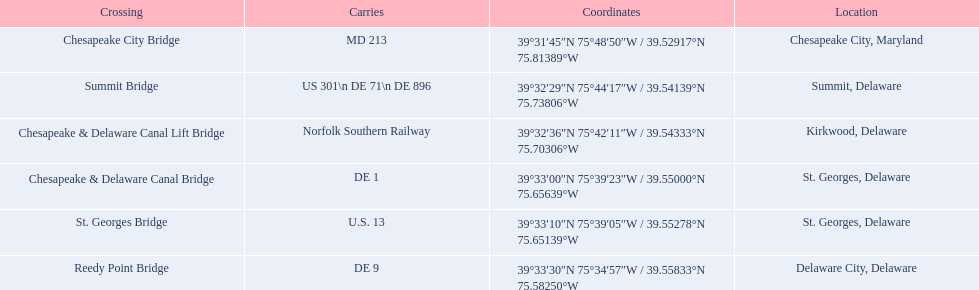Parse the full table in json format. {'header': ['Crossing', 'Carries', 'Coordinates', 'Location'], 'rows': [['Chesapeake City Bridge', 'MD 213', '39°31′45″N 75°48′50″W\ufeff / \ufeff39.52917°N 75.81389°W', 'Chesapeake City, Maryland'], ['Summit Bridge', 'US 301\\n DE 71\\n DE 896', '39°32′29″N 75°44′17″W\ufeff / \ufeff39.54139°N 75.73806°W', 'Summit, Delaware'], ['Chesapeake & Delaware Canal Lift Bridge', 'Norfolk Southern Railway', '39°32′36″N 75°42′11″W\ufeff / \ufeff39.54333°N 75.70306°W', 'Kirkwood, Delaware'], ['Chesapeake & Delaware Canal Bridge', 'DE 1', '39°33′00″N 75°39′23″W\ufeff / \ufeff39.55000°N 75.65639°W', 'St.\xa0Georges, Delaware'], ['St.\xa0Georges Bridge', 'U.S.\xa013', '39°33′10″N 75°39′05″W\ufeff / \ufeff39.55278°N 75.65139°W', 'St.\xa0Georges, Delaware'], ['Reedy Point Bridge', 'DE\xa09', '39°33′30″N 75°34′57″W\ufeff / \ufeff39.55833°N 75.58250°W', 'Delaware City, Delaware']]} Which are the bridges? Chesapeake City Bridge, Summit Bridge, Chesapeake & Delaware Canal Lift Bridge, Chesapeake & Delaware Canal Bridge, St. Georges Bridge, Reedy Point Bridge. Which are in delaware? Summit Bridge, Chesapeake & Delaware Canal Lift Bridge, Chesapeake & Delaware Canal Bridge, St. Georges Bridge, Reedy Point Bridge. Of these, which carries de 9? Reedy Point Bridge. 